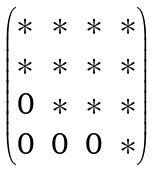Convert formula to latex. <formula><loc_0><loc_0><loc_500><loc_500>\begin{pmatrix} * & * & * & * \\ * & * & * & * \\ 0 & * & * & * \\ 0 & 0 & 0 & * \end{pmatrix}</formula> 